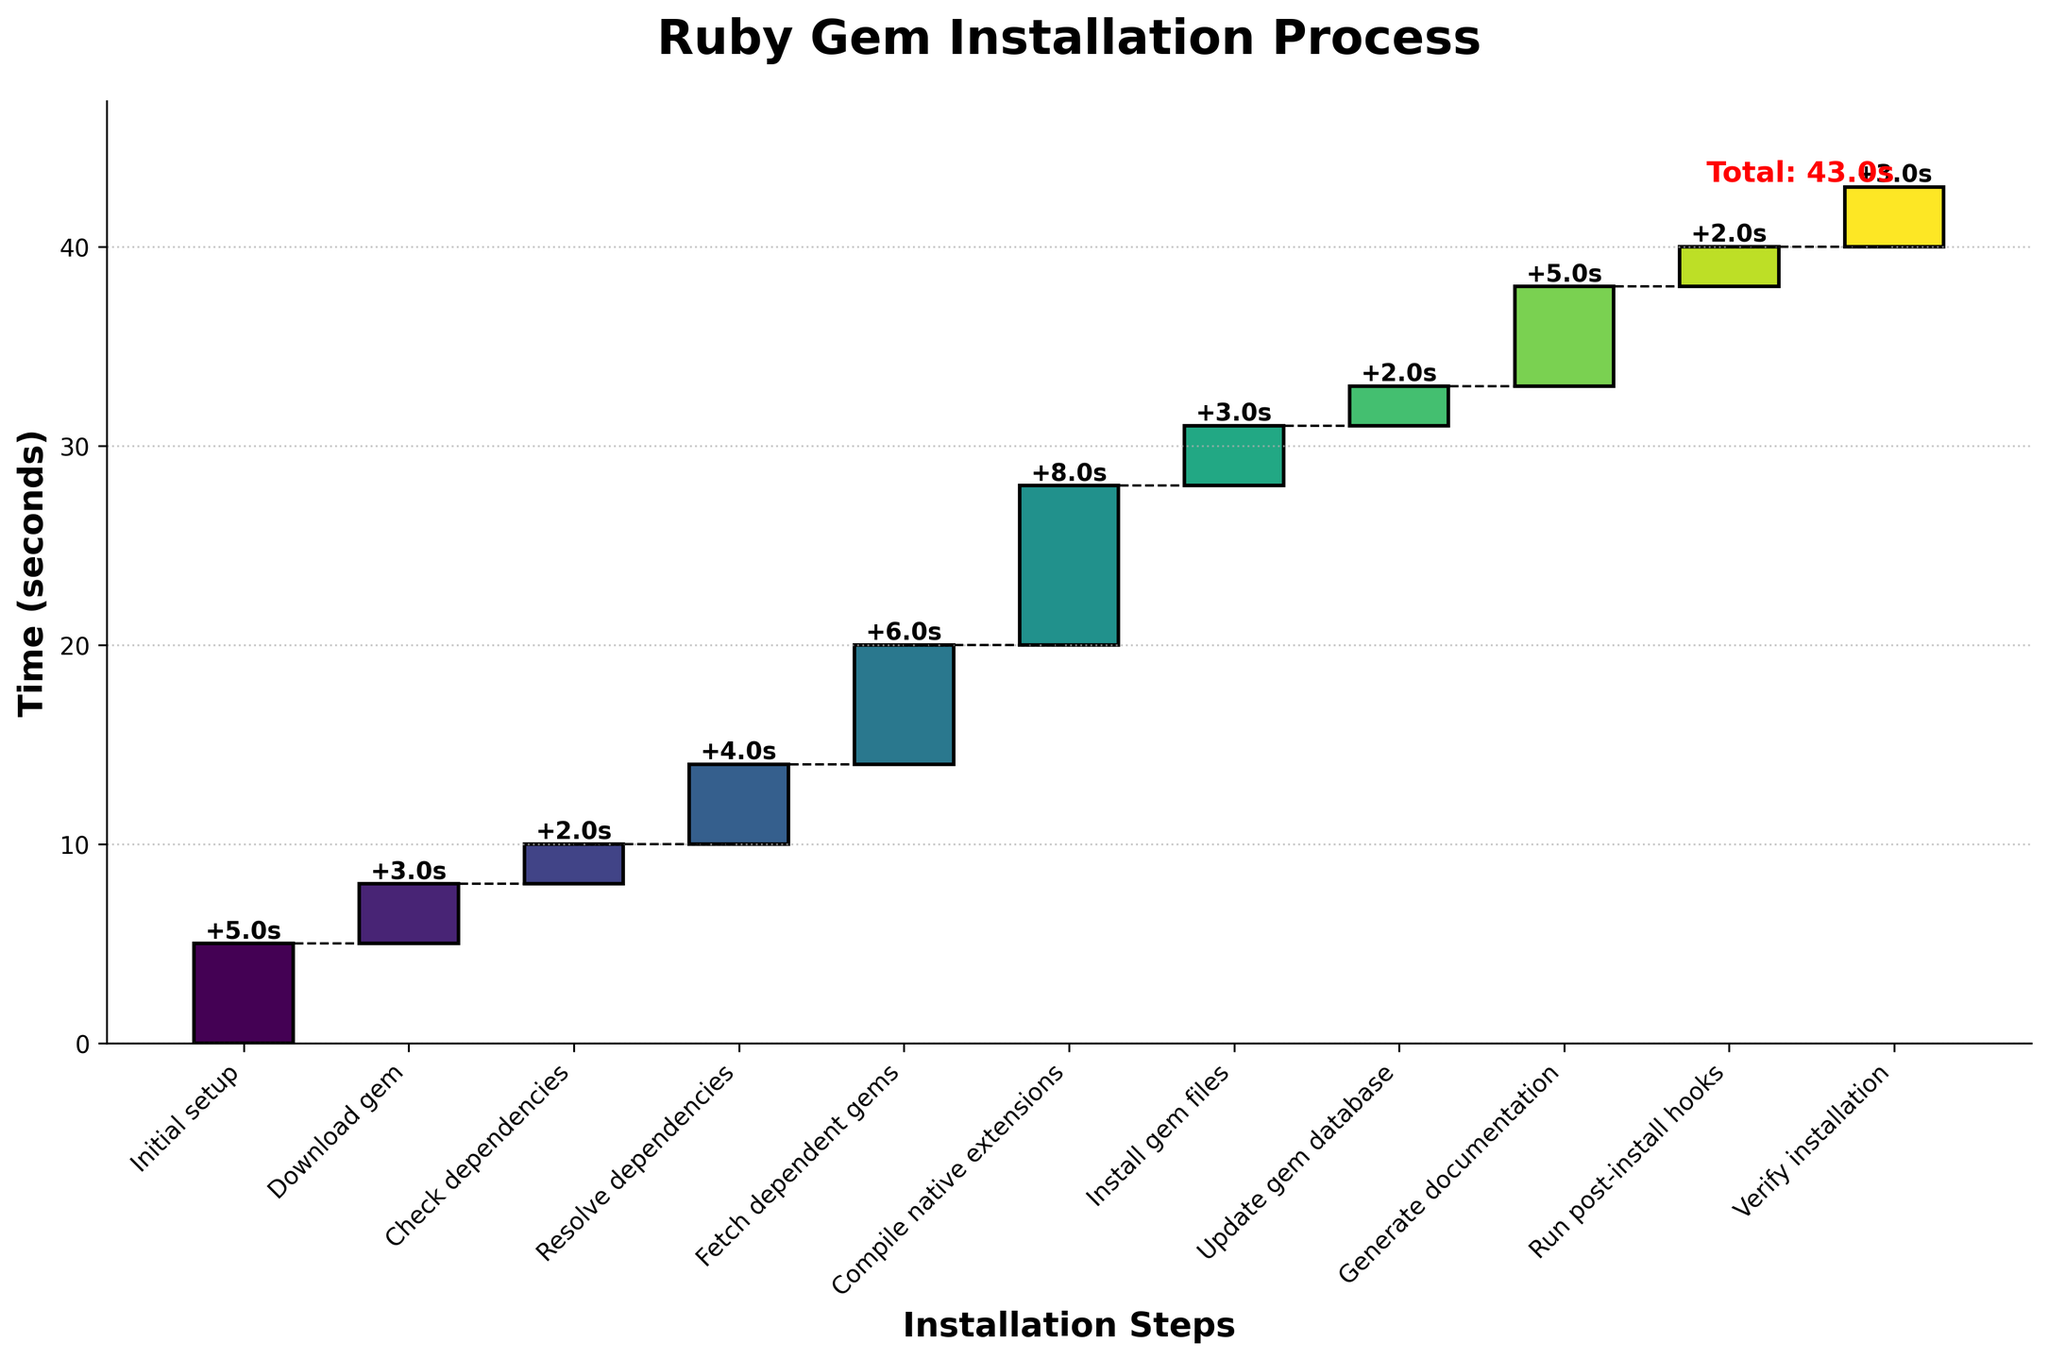What's the title of the figure? The title is displayed at the top of the figure. It provides a summary of what the chart represents: "Ruby Gem Installation Process".
Answer: Ruby Gem Installation Process Which installation step takes the longest time? To find the longest step, look at the bar heights indicating time for each step. The "Compile native extensions" step has the highest bar.
Answer: Compile native extensions What is the total time taken for the entire Ruby gem installation process? The total time is displayed as a label at the end of the final bar in the chart, showing the sum of all steps' times. The label reads "Total: 43.0s".
Answer: 43.0 seconds How much time is spent on 'Fetch dependent gems' and 'Compile native extensions' combined? Look for the bars corresponding to 'Fetch dependent gems' and 'Compile native extensions', which show times of 6 and 8 seconds respectively. Adding these gives 6 + 8 = 14 seconds.
Answer: 14 seconds What is the difference in time between the 'Initial setup' and 'Generate documentation' steps? The 'Initial setup' step takes 5 seconds and the 'Generate documentation' step takes 5 seconds. The difference in time is 5 - 5 = 0 seconds.
Answer: 0 seconds How much time is required from the 'Initial setup' to 'Update gem database' steps? Sum the times for each specified step: Initial setup (5), Download gem (3), Check dependencies (2), Resolve dependencies (4), Fetch dependent gems (6), Compile native extensions (8), Install gem files (3), and Update gem database (2). So, 5 + 3 + 2 + 4 + 6 + 8 + 3 + 2 = 33 seconds.
Answer: 33 seconds Are there any steps that take the same amount of time? If so, which ones? Check the heights of the bars to identify equal bars. 'Check dependencies' and 'Update gem database' both take 2 seconds each. 'Install gem files' and 'Verify installation' both take 3 seconds each. 'Initial setup' and 'Generate documentation' both take 5 seconds each.
Answer: Check dependencies & Update gem database, Install gem files & Verify installation, Initial setup & Generate documentation By how many seconds does 'Compile native extensions' exceed 'Install gem files'? Subtract the time for 'Install gem files' (3 seconds) from the time for 'Compile native extensions' (8 seconds). 8 - 3 = 5 seconds.
Answer: 5 seconds What percentage of the total installation time is spent on 'Download gem'? First, determine the total installation time, which is 43 seconds. Then, divide the 'Download gem' time (3 seconds) by the total time and multiply by 100 to get the percentage: (3/43) * 100 ≈ 6.98%.
Answer: 6.98% Which step directly follows 'Resolve dependencies' in terms of time taken? Look at the sequence of steps. After 'Resolve dependencies', the next step is 'Fetch dependent gems' which takes 6 seconds.
Answer: Fetch dependent gems 